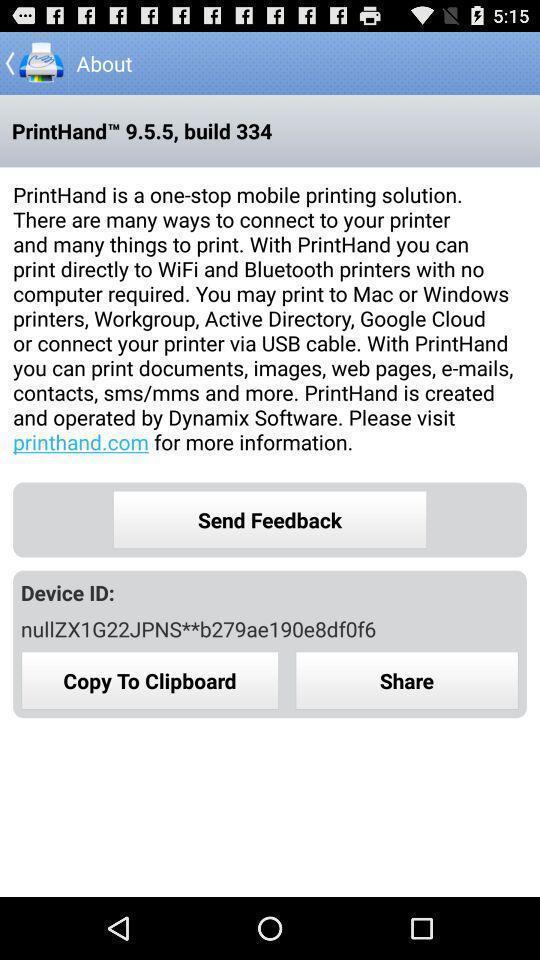Summarize the information in this screenshot. Screen shows about details in a printer app. 